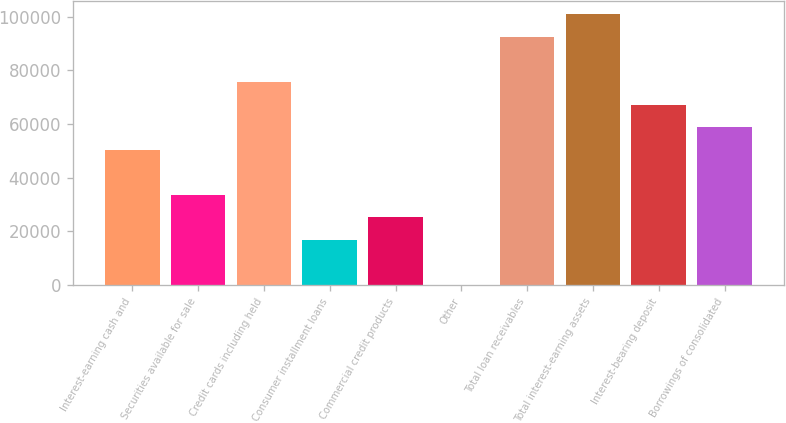<chart> <loc_0><loc_0><loc_500><loc_500><bar_chart><fcel>Interest-earning cash and<fcel>Securities available for sale<fcel>Credit cards including held<fcel>Consumer installment loans<fcel>Commercial credit products<fcel>Other<fcel>Total loan receivables<fcel>Total interest-earning assets<fcel>Interest-bearing deposit<fcel>Borrowings of consolidated<nl><fcel>50435<fcel>33642<fcel>75624.5<fcel>16849<fcel>25245.5<fcel>56<fcel>92417.5<fcel>100814<fcel>67228<fcel>58831.5<nl></chart> 